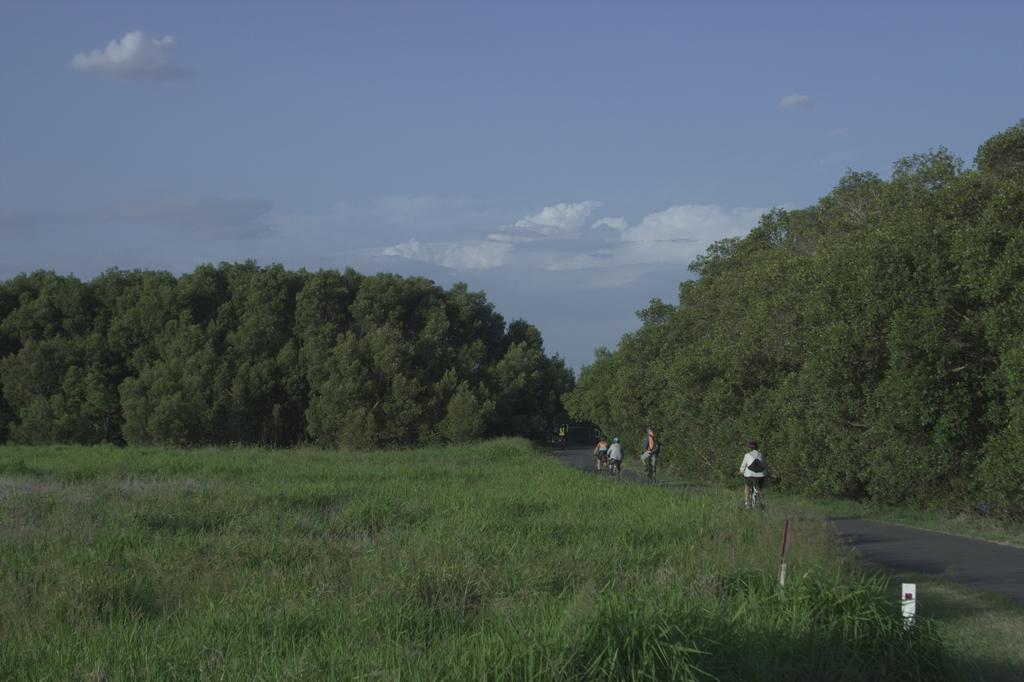What type of vegetation is visible in the front of the image? There is grass in the front of the image. What is located in the center of the image? There are persons in the center of the image. What can be seen in the background of the image? There are trees in the background of the image. How would you describe the sky in the image? The sky is cloudy in the image. What type of effect does the riddle have on the persons in the image? There is no riddle present in the image, so it cannot have any effect on the persons. How many bikes are visible in the image? There are no bikes visible in the image. 